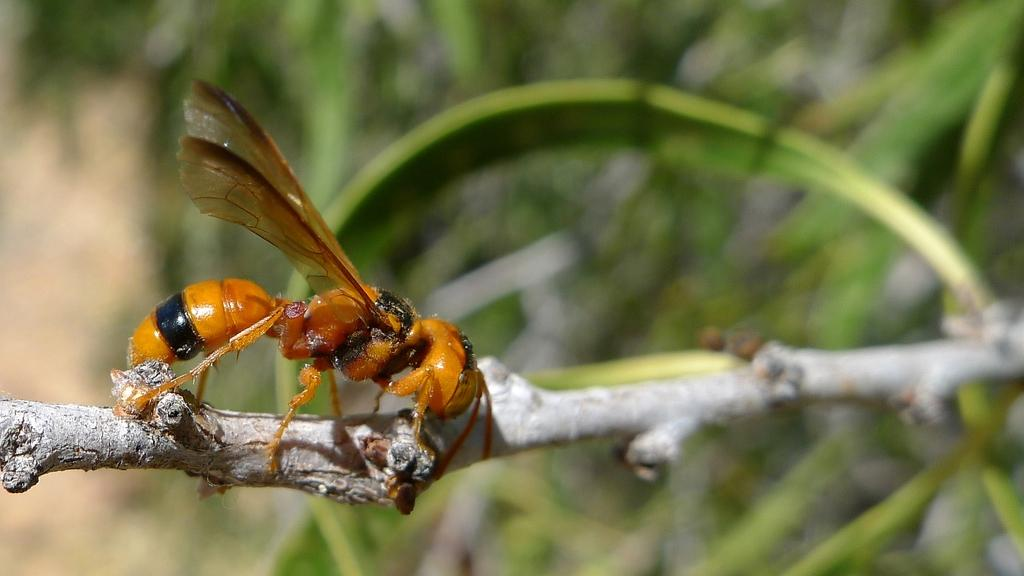What is located on the branch of the tree in the image? There is there an insect on the branch of a tree in the image? Can you describe the background of the image? The background of the image is blurry. What type of ornament is hanging from the branch of the tree in the image? There is no ornament present in the image; it only features an insect on the branch of a tree. 